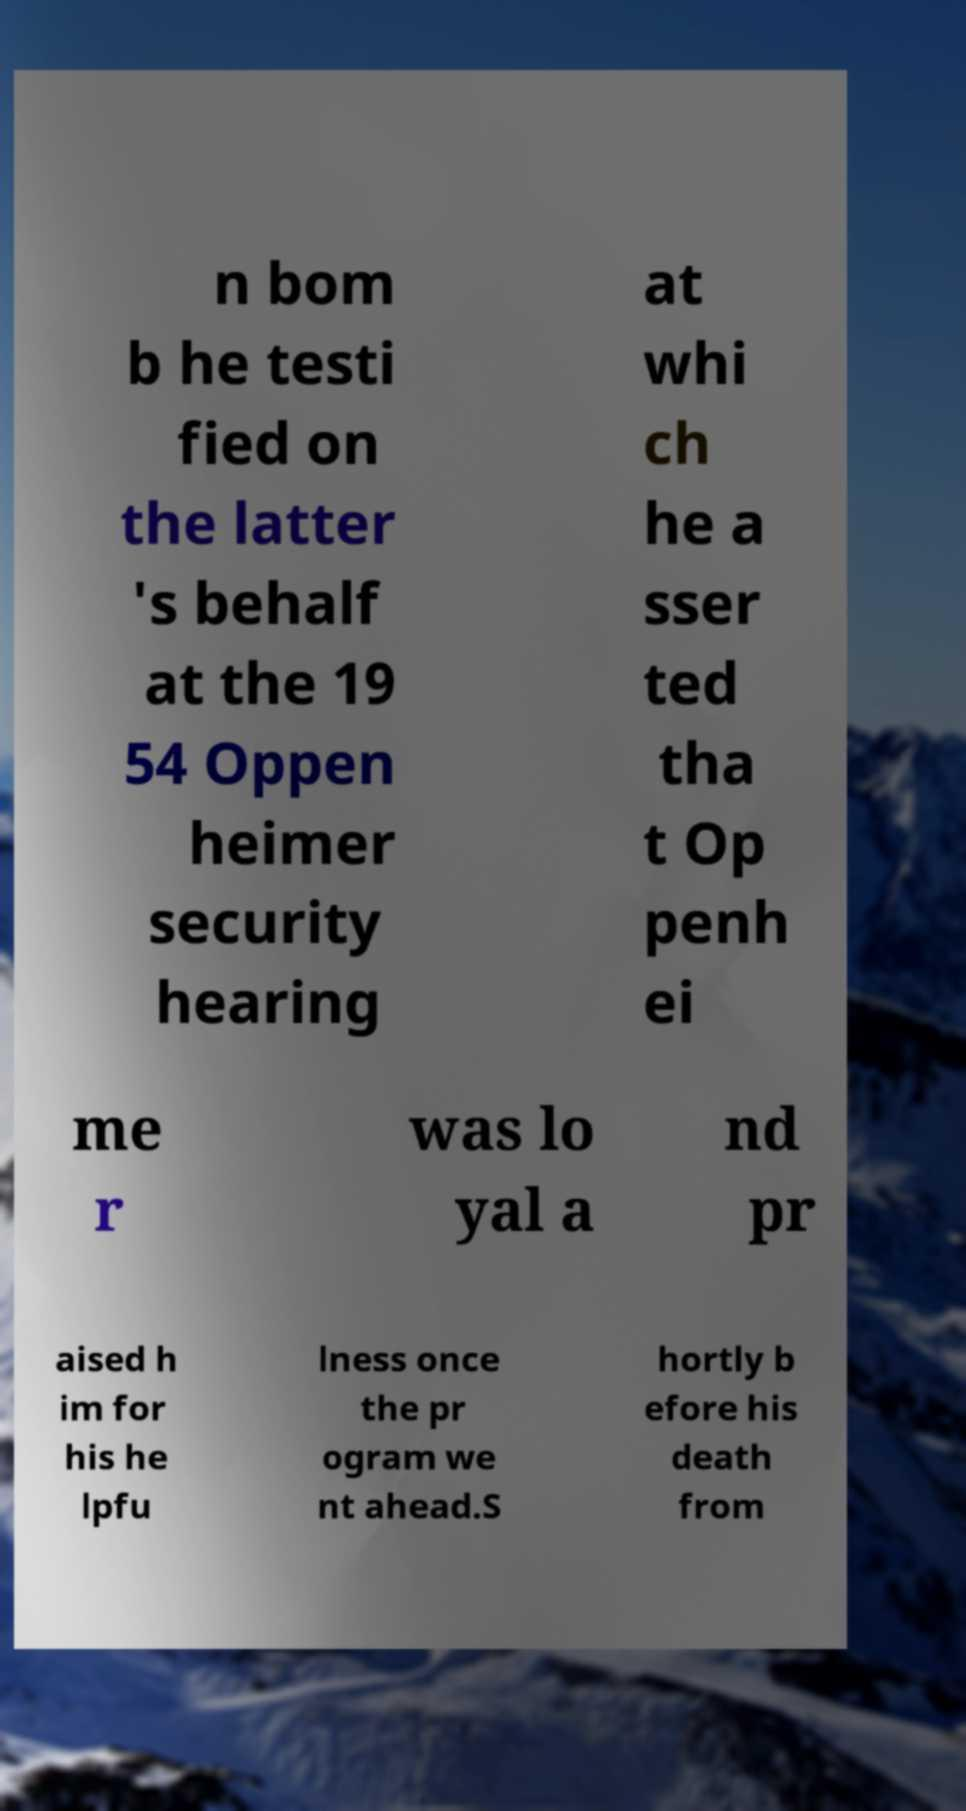Could you extract and type out the text from this image? n bom b he testi fied on the latter 's behalf at the 19 54 Oppen heimer security hearing at whi ch he a sser ted tha t Op penh ei me r was lo yal a nd pr aised h im for his he lpfu lness once the pr ogram we nt ahead.S hortly b efore his death from 